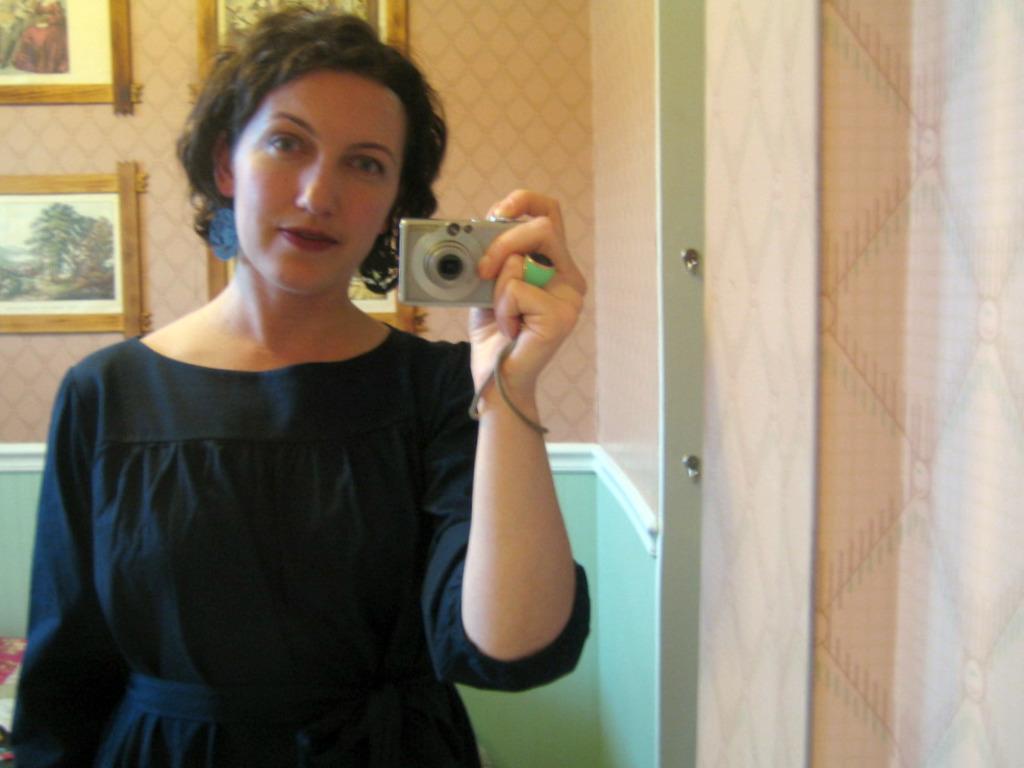Could you give a brief overview of what you see in this image? There is a woman standing and holding a camera. At background I can see photo frames which are attached to the wall. She is wearing a black dress. 